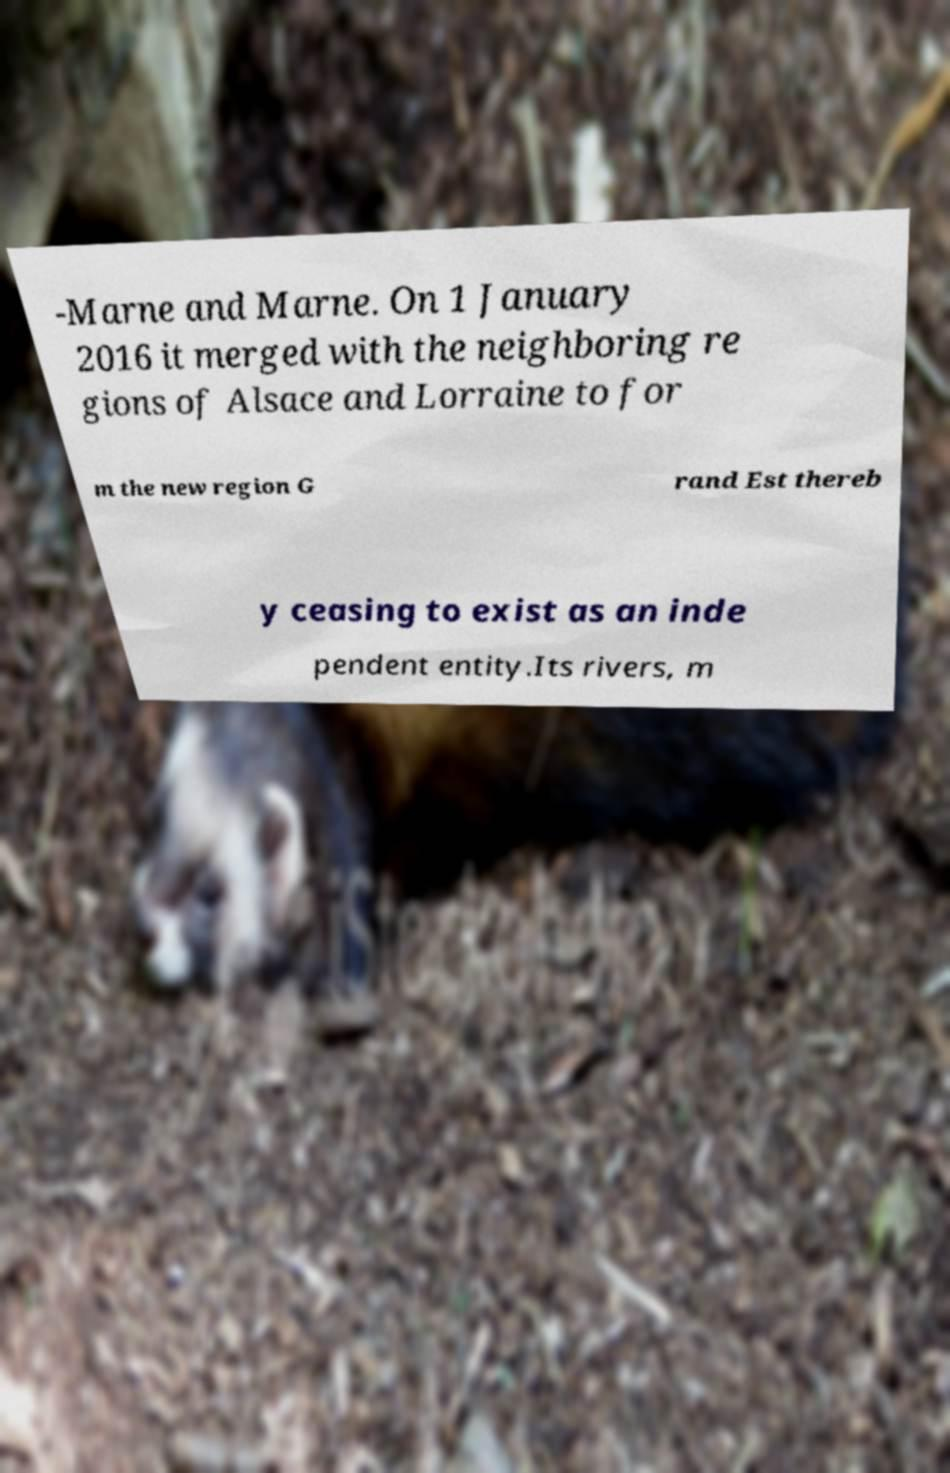For documentation purposes, I need the text within this image transcribed. Could you provide that? -Marne and Marne. On 1 January 2016 it merged with the neighboring re gions of Alsace and Lorraine to for m the new region G rand Est thereb y ceasing to exist as an inde pendent entity.Its rivers, m 